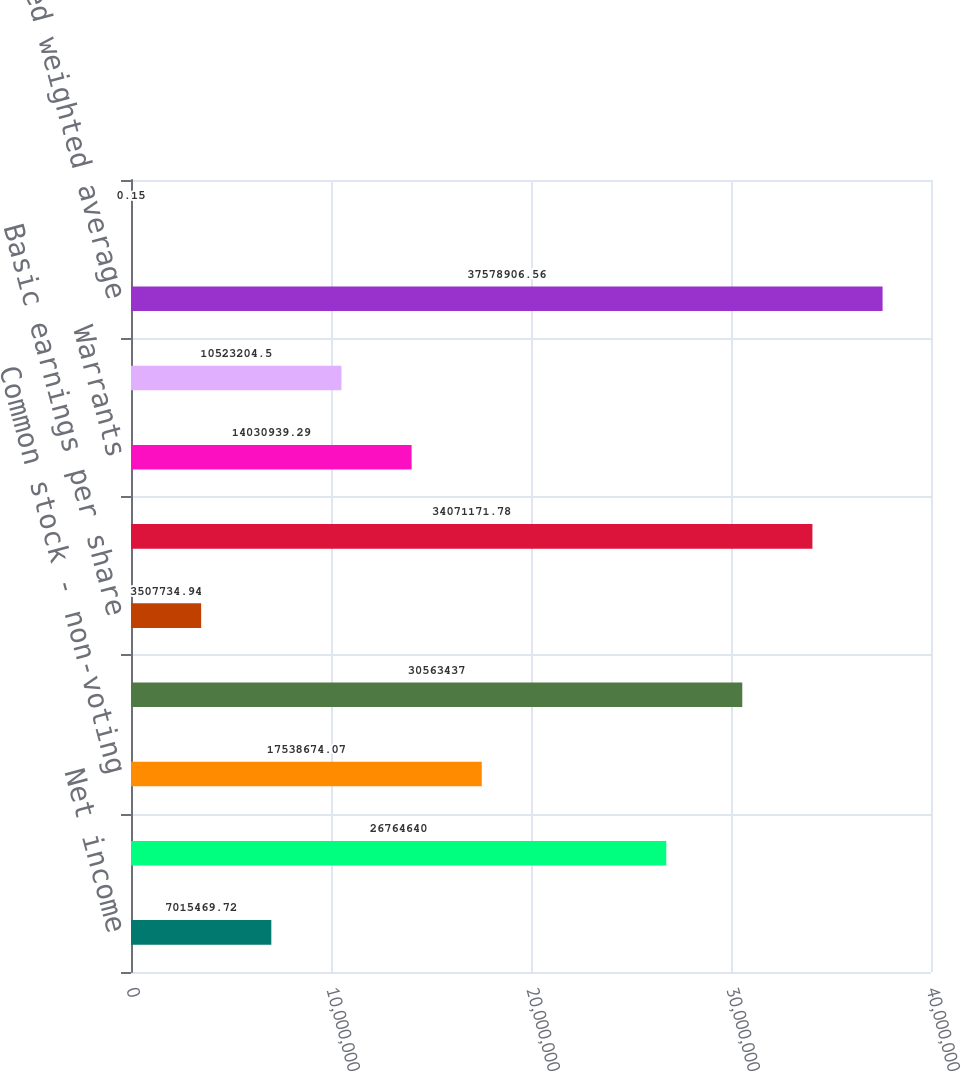<chart> <loc_0><loc_0><loc_500><loc_500><bar_chart><fcel>Net income<fcel>Common stock - voting<fcel>Common stock - non-voting<fcel>Basic weighted average shares<fcel>Basic earnings per share<fcel>Weight average shares<fcel>Warrants<fcel>Stock options and restricted<fcel>Diluted weighted average<fcel>Diluted earnings per share<nl><fcel>7.01547e+06<fcel>2.67646e+07<fcel>1.75387e+07<fcel>3.05634e+07<fcel>3.50773e+06<fcel>3.40712e+07<fcel>1.40309e+07<fcel>1.05232e+07<fcel>3.75789e+07<fcel>0.15<nl></chart> 